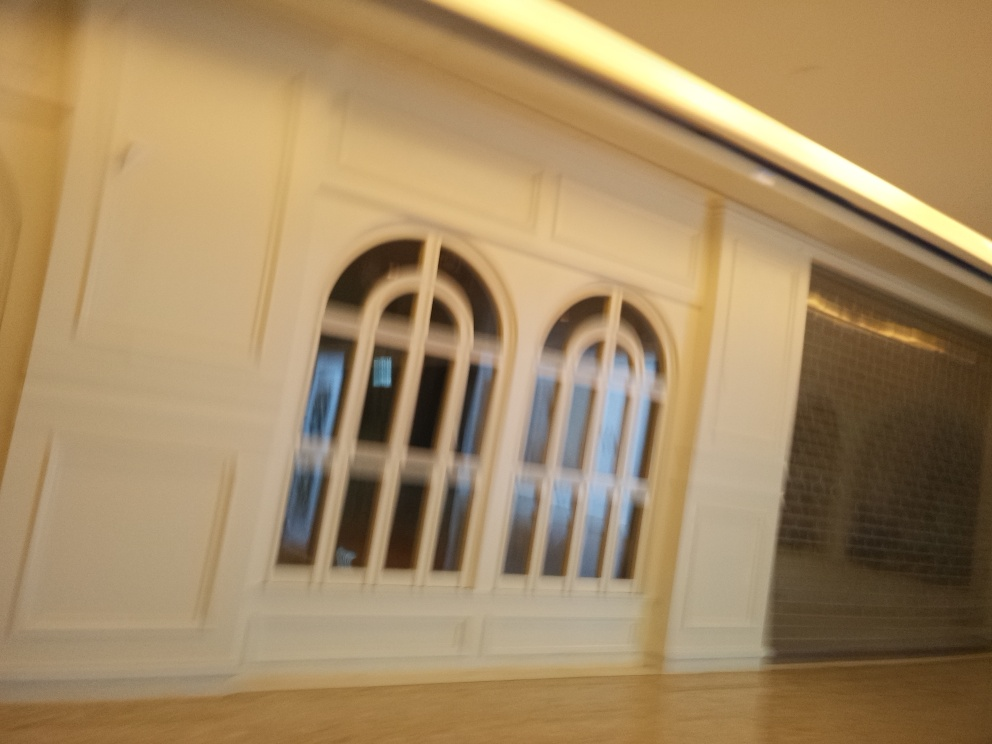Can you describe the architectural style of the building in the image? Although the image is blurred and details are not clear, the visible elements suggest a classical architectural influence with symmetrically aligned windows and what appears to be decorative moulding. Such features are characteristic of neoclassical or Georgian styles often found in formal buildings. 